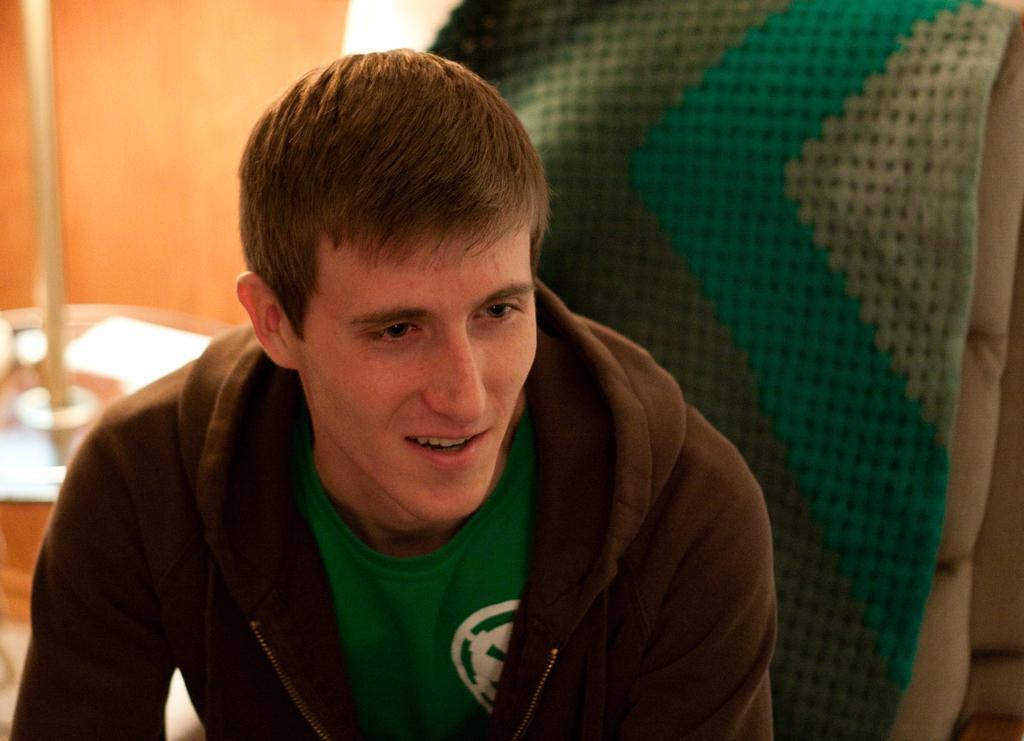Please provide a concise description of this image. In this image we can see one man is sitting, he is wearing hoodie with green t-shirt. Behind him one chair is present. 